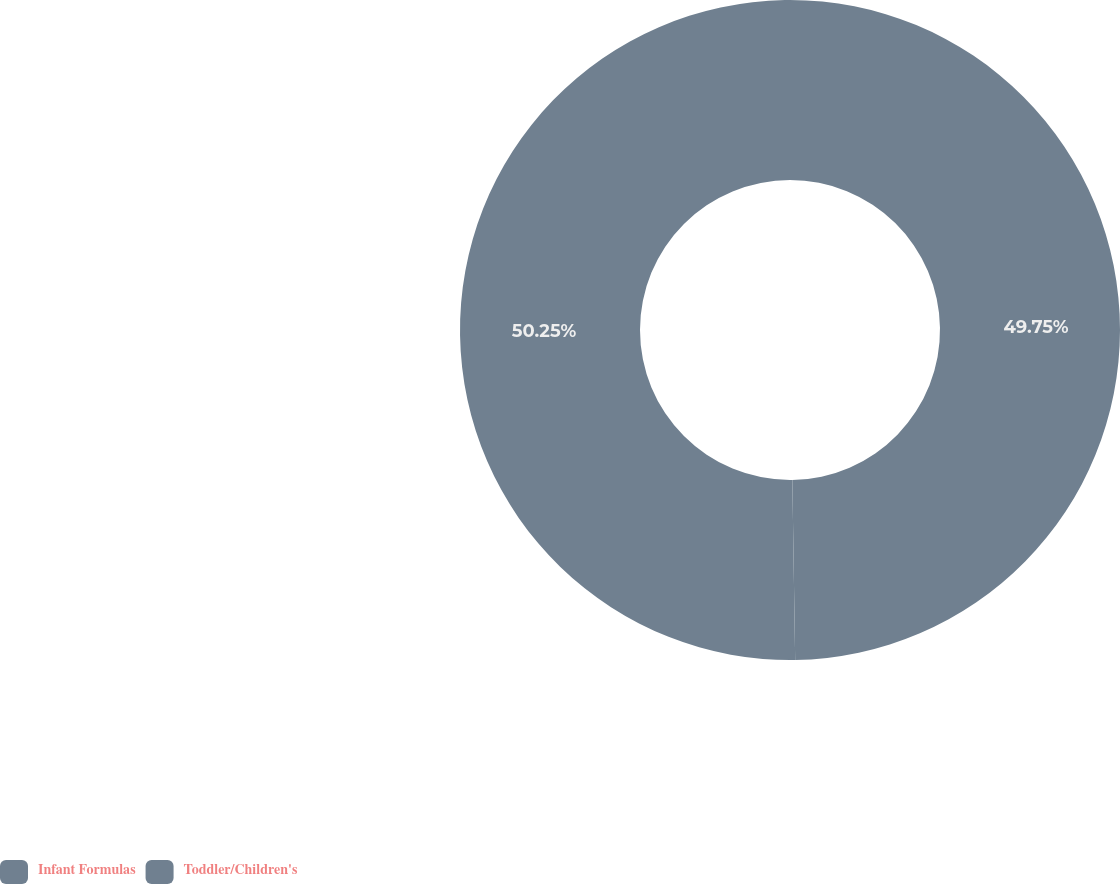Convert chart to OTSL. <chart><loc_0><loc_0><loc_500><loc_500><pie_chart><fcel>Infant Formulas<fcel>Toddler/Children's<nl><fcel>49.75%<fcel>50.25%<nl></chart> 